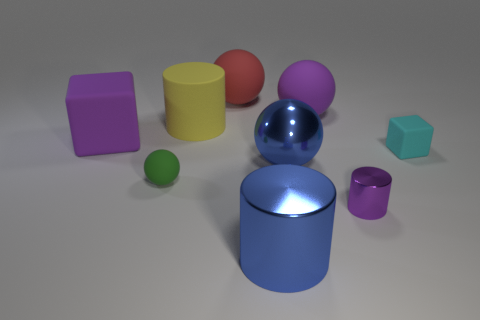Can you describe the lighting in the scene? The lighting in this scene seems to be coming from above, as indicated by the shadows directly under the objects and the bright highlight on the top of the central cylinder and sphere. 